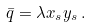Convert formula to latex. <formula><loc_0><loc_0><loc_500><loc_500>\bar { q } = \lambda x _ { s } y _ { s } \, .</formula> 